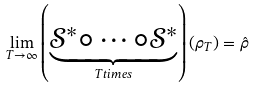Convert formula to latex. <formula><loc_0><loc_0><loc_500><loc_500>\lim _ { T \rightarrow \infty } \left ( \underbrace { \mathcal { S } ^ { * } \circ \cdots \circ \mathcal { S } ^ { * } } _ { T t i m e s } \right ) ( \rho _ { T } ) = \hat { \rho }</formula> 